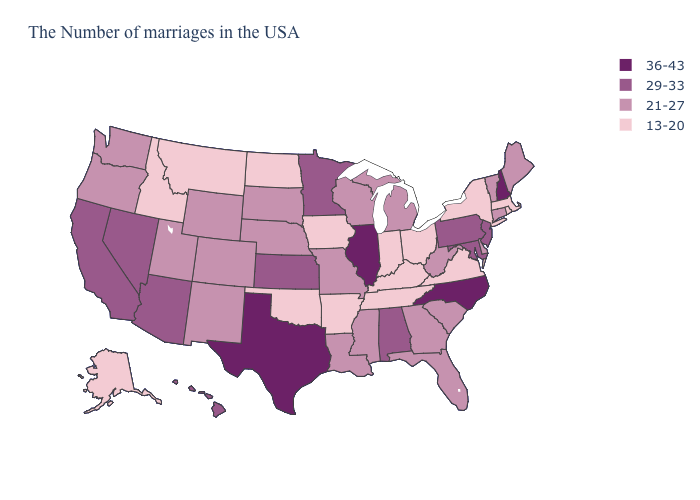Does Nevada have the lowest value in the USA?
Short answer required. No. Name the states that have a value in the range 13-20?
Concise answer only. Massachusetts, Rhode Island, New York, Virginia, Ohio, Kentucky, Indiana, Tennessee, Arkansas, Iowa, Oklahoma, North Dakota, Montana, Idaho, Alaska. Does the map have missing data?
Write a very short answer. No. Does Kansas have the highest value in the MidWest?
Concise answer only. No. What is the value of Montana?
Answer briefly. 13-20. Does Kansas have the same value as Nebraska?
Quick response, please. No. Among the states that border Arkansas , does Texas have the highest value?
Write a very short answer. Yes. What is the value of Nevada?
Be succinct. 29-33. Does the map have missing data?
Give a very brief answer. No. Does Indiana have the lowest value in the MidWest?
Concise answer only. Yes. Does New Hampshire have the highest value in the USA?
Give a very brief answer. Yes. Which states have the lowest value in the MidWest?
Short answer required. Ohio, Indiana, Iowa, North Dakota. What is the highest value in states that border Kansas?
Keep it brief. 21-27. Does Virginia have the lowest value in the USA?
Be succinct. Yes. Which states have the lowest value in the USA?
Give a very brief answer. Massachusetts, Rhode Island, New York, Virginia, Ohio, Kentucky, Indiana, Tennessee, Arkansas, Iowa, Oklahoma, North Dakota, Montana, Idaho, Alaska. 